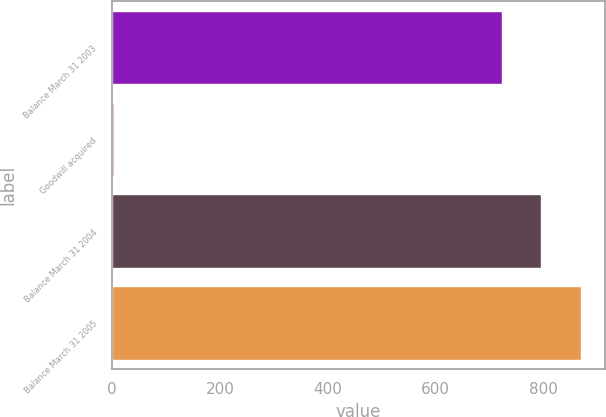Convert chart to OTSL. <chart><loc_0><loc_0><loc_500><loc_500><bar_chart><fcel>Balance March 31 2003<fcel>Goodwill acquired<fcel>Balance March 31 2004<fcel>Balance March 31 2005<nl><fcel>722.1<fcel>3.1<fcel>796.19<fcel>870.28<nl></chart> 